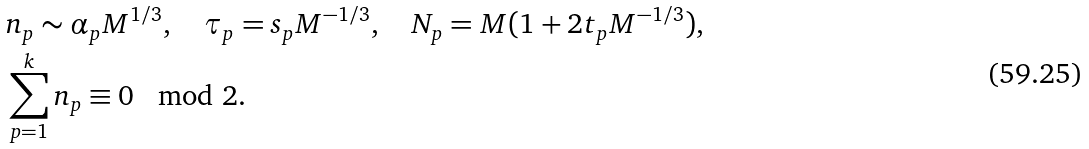<formula> <loc_0><loc_0><loc_500><loc_500>& n _ { p } \sim \alpha _ { p } M ^ { 1 / 3 } , \quad \tau _ { p } = s _ { p } M ^ { - 1 / 3 } , \quad N _ { p } = M ( 1 + 2 t _ { p } M ^ { - 1 / 3 } ) , \\ & \sum _ { p = 1 } ^ { k } n _ { p } \equiv 0 \mod 2 .</formula> 